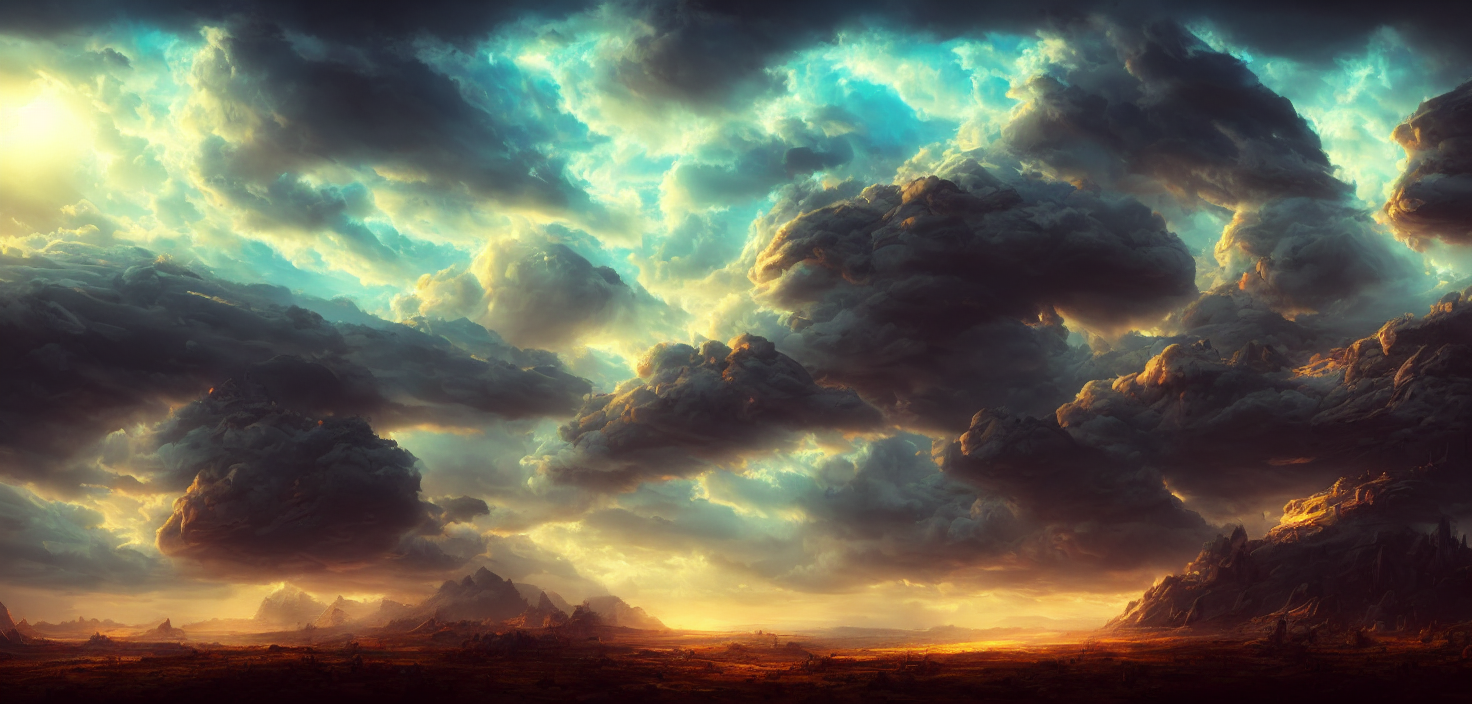Is there any sign of human or animal presence in this image? There is no explicit sign of human or animal presence in this image. The focus is entirely on the natural elements such as the clouds and the landscape, which conveys a sense of untouched wilderness and solitude. 